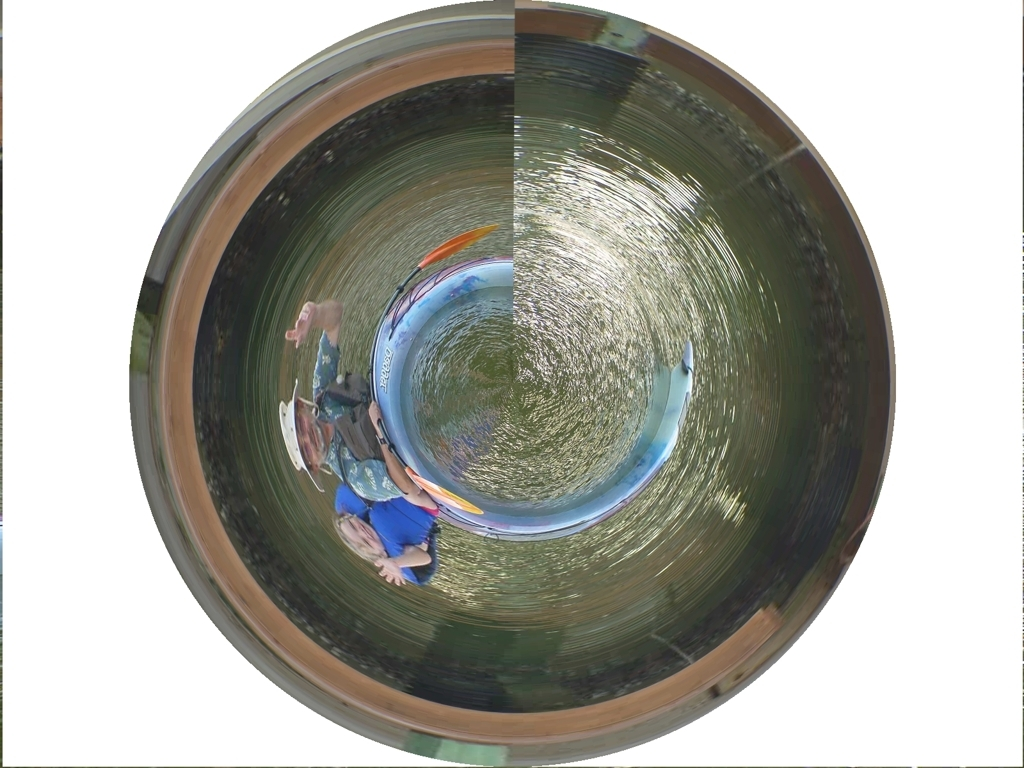What are the artistic implications of using such an effect in photography? Using a 'tiny planet' effect can introduce a surreal and whimsical quality to photography. It challenges the viewer's perception of space and scale, and it can evoke feelings of curiosity and wonder. Artistically, it can symbolize isolated worlds, encapsulated environments, or highlight the playful manipulation of reality in digital art. 